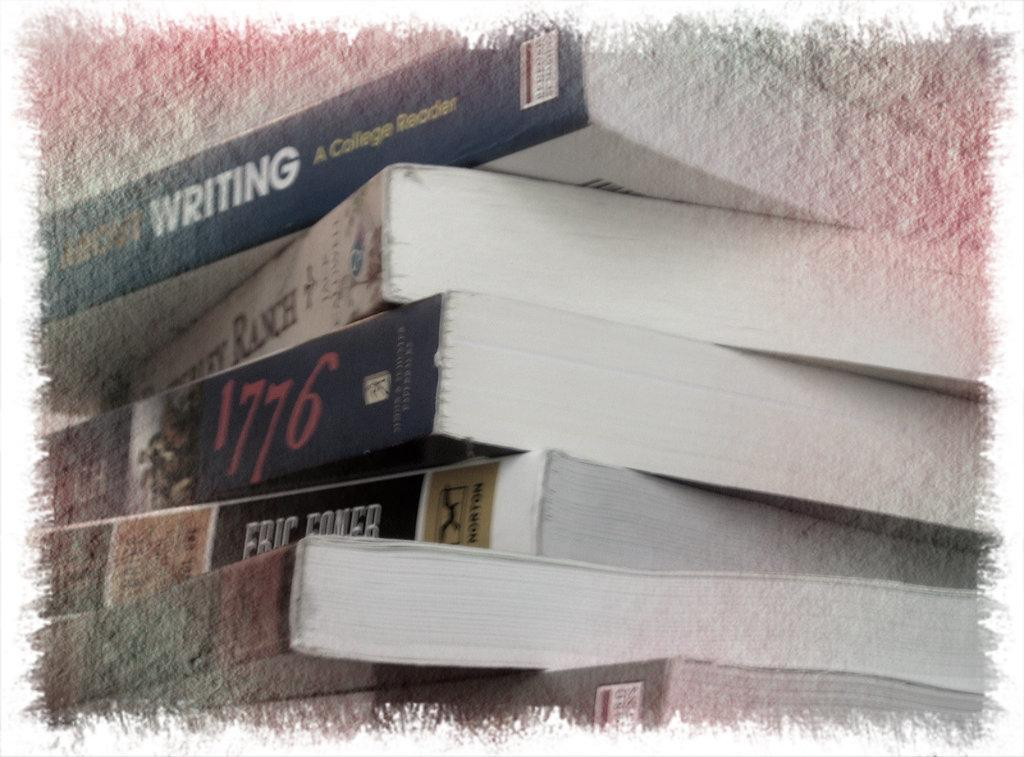<image>
Create a compact narrative representing the image presented. The book "1776" is in the middle of a stack of other books. 